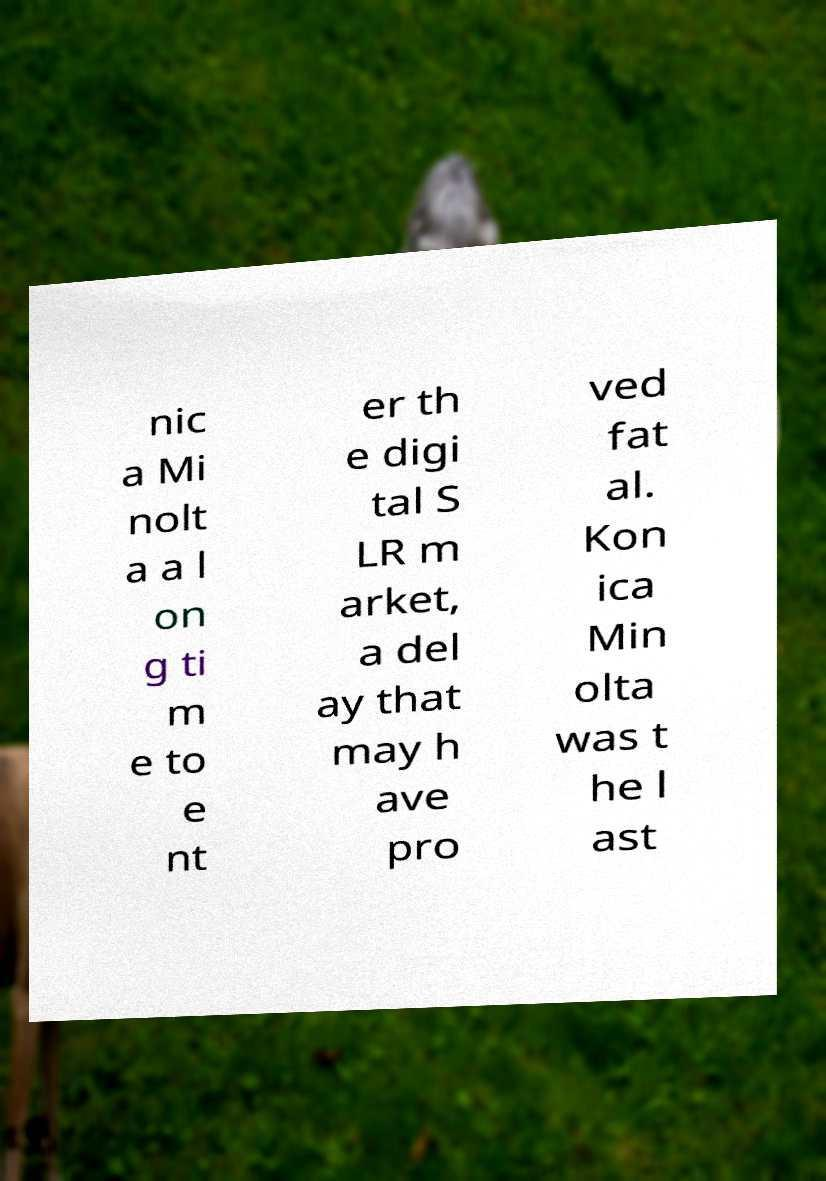Please identify and transcribe the text found in this image. nic a Mi nolt a a l on g ti m e to e nt er th e digi tal S LR m arket, a del ay that may h ave pro ved fat al. Kon ica Min olta was t he l ast 